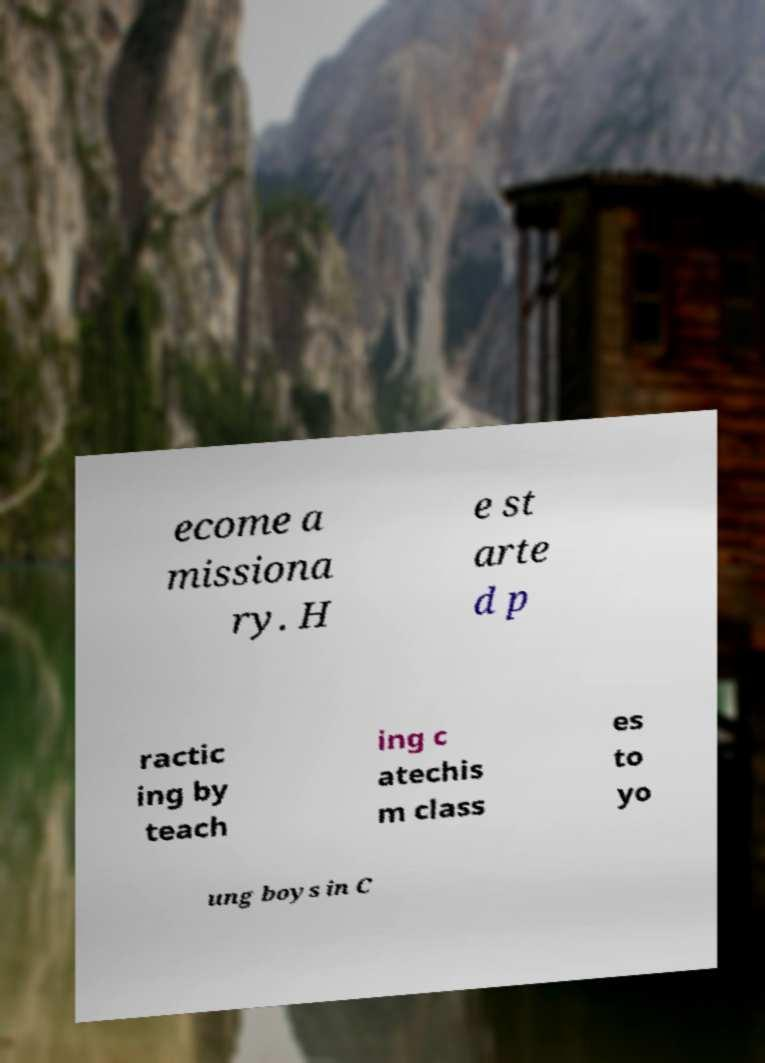Can you read and provide the text displayed in the image?This photo seems to have some interesting text. Can you extract and type it out for me? ecome a missiona ry. H e st arte d p ractic ing by teach ing c atechis m class es to yo ung boys in C 